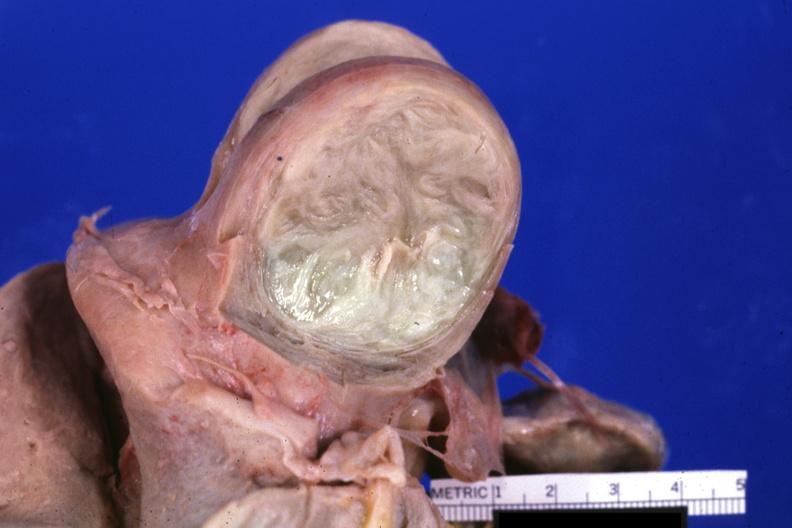where does this part belong to?
Answer the question using a single word or phrase. Female reproductive system 